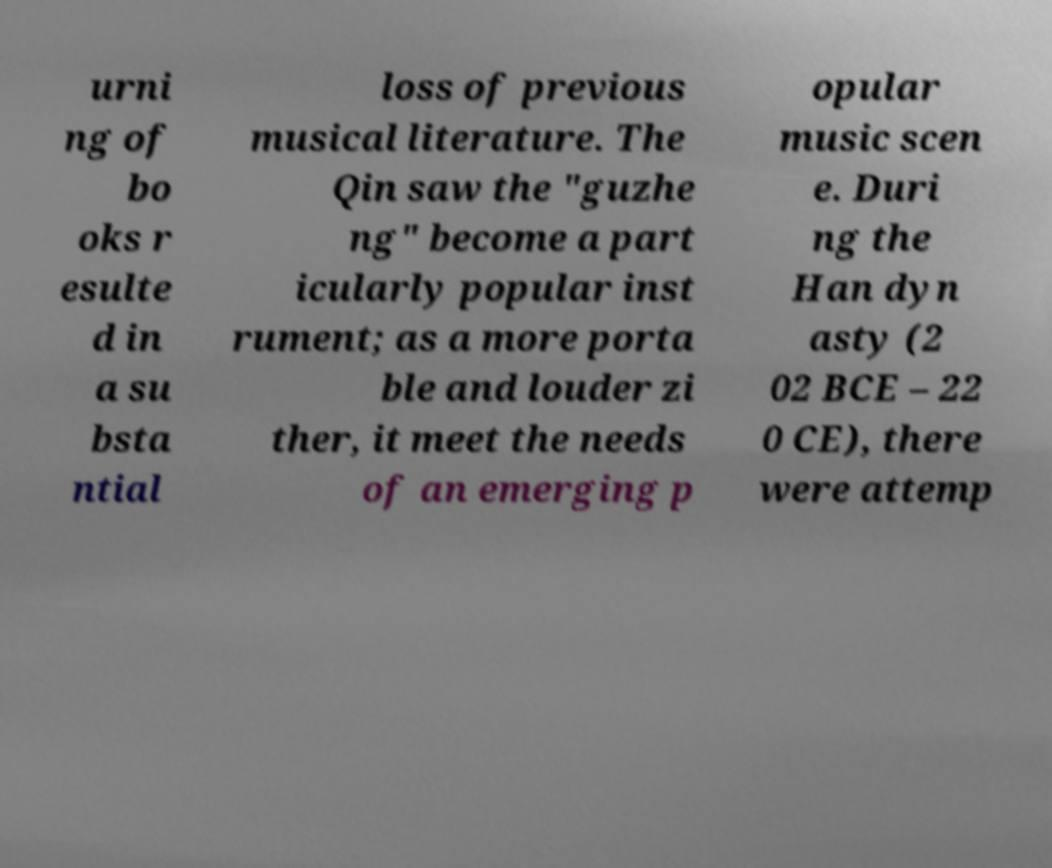Please identify and transcribe the text found in this image. urni ng of bo oks r esulte d in a su bsta ntial loss of previous musical literature. The Qin saw the "guzhe ng" become a part icularly popular inst rument; as a more porta ble and louder zi ther, it meet the needs of an emerging p opular music scen e. Duri ng the Han dyn asty (2 02 BCE – 22 0 CE), there were attemp 